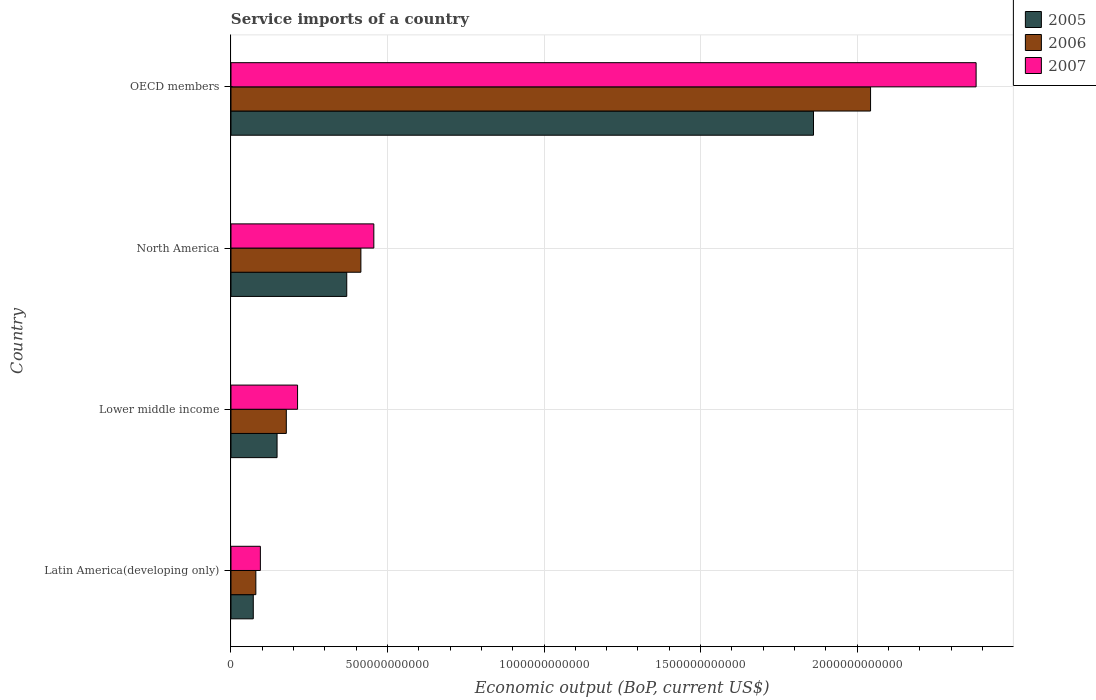How many different coloured bars are there?
Your response must be concise. 3. Are the number of bars per tick equal to the number of legend labels?
Keep it short and to the point. Yes. Are the number of bars on each tick of the Y-axis equal?
Provide a short and direct response. Yes. How many bars are there on the 2nd tick from the top?
Your answer should be compact. 3. How many bars are there on the 3rd tick from the bottom?
Provide a succinct answer. 3. What is the service imports in 2007 in North America?
Your response must be concise. 4.56e+11. Across all countries, what is the maximum service imports in 2006?
Give a very brief answer. 2.04e+12. Across all countries, what is the minimum service imports in 2005?
Offer a terse response. 7.13e+1. In which country was the service imports in 2007 minimum?
Make the answer very short. Latin America(developing only). What is the total service imports in 2006 in the graph?
Your answer should be very brief. 2.71e+12. What is the difference between the service imports in 2005 in North America and that in OECD members?
Your response must be concise. -1.49e+12. What is the difference between the service imports in 2005 in Lower middle income and the service imports in 2007 in Latin America(developing only)?
Ensure brevity in your answer.  5.33e+1. What is the average service imports in 2007 per country?
Make the answer very short. 7.86e+11. What is the difference between the service imports in 2007 and service imports in 2005 in Latin America(developing only)?
Give a very brief answer. 2.26e+1. In how many countries, is the service imports in 2006 greater than 800000000000 US$?
Provide a succinct answer. 1. What is the ratio of the service imports in 2007 in Lower middle income to that in OECD members?
Your answer should be compact. 0.09. Is the service imports in 2005 in Lower middle income less than that in North America?
Provide a succinct answer. Yes. What is the difference between the highest and the second highest service imports in 2007?
Offer a very short reply. 1.92e+12. What is the difference between the highest and the lowest service imports in 2005?
Ensure brevity in your answer.  1.79e+12. In how many countries, is the service imports in 2006 greater than the average service imports in 2006 taken over all countries?
Your answer should be very brief. 1. What does the 1st bar from the top in Latin America(developing only) represents?
Provide a succinct answer. 2007. What does the 2nd bar from the bottom in Lower middle income represents?
Provide a succinct answer. 2006. Is it the case that in every country, the sum of the service imports in 2005 and service imports in 2006 is greater than the service imports in 2007?
Make the answer very short. Yes. What is the difference between two consecutive major ticks on the X-axis?
Provide a succinct answer. 5.00e+11. Where does the legend appear in the graph?
Ensure brevity in your answer.  Top right. How many legend labels are there?
Provide a short and direct response. 3. What is the title of the graph?
Keep it short and to the point. Service imports of a country. Does "1982" appear as one of the legend labels in the graph?
Your answer should be very brief. No. What is the label or title of the X-axis?
Give a very brief answer. Economic output (BoP, current US$). What is the label or title of the Y-axis?
Ensure brevity in your answer.  Country. What is the Economic output (BoP, current US$) of 2005 in Latin America(developing only)?
Ensure brevity in your answer.  7.13e+1. What is the Economic output (BoP, current US$) in 2006 in Latin America(developing only)?
Provide a succinct answer. 7.94e+1. What is the Economic output (BoP, current US$) in 2007 in Latin America(developing only)?
Ensure brevity in your answer.  9.39e+1. What is the Economic output (BoP, current US$) in 2005 in Lower middle income?
Keep it short and to the point. 1.47e+11. What is the Economic output (BoP, current US$) of 2006 in Lower middle income?
Ensure brevity in your answer.  1.77e+11. What is the Economic output (BoP, current US$) in 2007 in Lower middle income?
Provide a short and direct response. 2.13e+11. What is the Economic output (BoP, current US$) in 2005 in North America?
Your answer should be compact. 3.70e+11. What is the Economic output (BoP, current US$) of 2006 in North America?
Ensure brevity in your answer.  4.15e+11. What is the Economic output (BoP, current US$) of 2007 in North America?
Your response must be concise. 4.56e+11. What is the Economic output (BoP, current US$) in 2005 in OECD members?
Your answer should be very brief. 1.86e+12. What is the Economic output (BoP, current US$) of 2006 in OECD members?
Provide a short and direct response. 2.04e+12. What is the Economic output (BoP, current US$) in 2007 in OECD members?
Give a very brief answer. 2.38e+12. Across all countries, what is the maximum Economic output (BoP, current US$) in 2005?
Your answer should be very brief. 1.86e+12. Across all countries, what is the maximum Economic output (BoP, current US$) of 2006?
Offer a very short reply. 2.04e+12. Across all countries, what is the maximum Economic output (BoP, current US$) of 2007?
Offer a very short reply. 2.38e+12. Across all countries, what is the minimum Economic output (BoP, current US$) in 2005?
Make the answer very short. 7.13e+1. Across all countries, what is the minimum Economic output (BoP, current US$) of 2006?
Provide a short and direct response. 7.94e+1. Across all countries, what is the minimum Economic output (BoP, current US$) in 2007?
Provide a short and direct response. 9.39e+1. What is the total Economic output (BoP, current US$) of 2005 in the graph?
Offer a terse response. 2.45e+12. What is the total Economic output (BoP, current US$) in 2006 in the graph?
Your response must be concise. 2.71e+12. What is the total Economic output (BoP, current US$) in 2007 in the graph?
Ensure brevity in your answer.  3.14e+12. What is the difference between the Economic output (BoP, current US$) in 2005 in Latin America(developing only) and that in Lower middle income?
Your answer should be compact. -7.59e+1. What is the difference between the Economic output (BoP, current US$) in 2006 in Latin America(developing only) and that in Lower middle income?
Keep it short and to the point. -9.73e+1. What is the difference between the Economic output (BoP, current US$) in 2007 in Latin America(developing only) and that in Lower middle income?
Keep it short and to the point. -1.19e+11. What is the difference between the Economic output (BoP, current US$) of 2005 in Latin America(developing only) and that in North America?
Provide a short and direct response. -2.99e+11. What is the difference between the Economic output (BoP, current US$) in 2006 in Latin America(developing only) and that in North America?
Keep it short and to the point. -3.36e+11. What is the difference between the Economic output (BoP, current US$) in 2007 in Latin America(developing only) and that in North America?
Provide a succinct answer. -3.62e+11. What is the difference between the Economic output (BoP, current US$) of 2005 in Latin America(developing only) and that in OECD members?
Offer a terse response. -1.79e+12. What is the difference between the Economic output (BoP, current US$) of 2006 in Latin America(developing only) and that in OECD members?
Keep it short and to the point. -1.96e+12. What is the difference between the Economic output (BoP, current US$) in 2007 in Latin America(developing only) and that in OECD members?
Offer a terse response. -2.29e+12. What is the difference between the Economic output (BoP, current US$) of 2005 in Lower middle income and that in North America?
Make the answer very short. -2.23e+11. What is the difference between the Economic output (BoP, current US$) in 2006 in Lower middle income and that in North America?
Ensure brevity in your answer.  -2.38e+11. What is the difference between the Economic output (BoP, current US$) in 2007 in Lower middle income and that in North America?
Make the answer very short. -2.44e+11. What is the difference between the Economic output (BoP, current US$) of 2005 in Lower middle income and that in OECD members?
Make the answer very short. -1.71e+12. What is the difference between the Economic output (BoP, current US$) of 2006 in Lower middle income and that in OECD members?
Offer a terse response. -1.87e+12. What is the difference between the Economic output (BoP, current US$) of 2007 in Lower middle income and that in OECD members?
Your answer should be compact. -2.17e+12. What is the difference between the Economic output (BoP, current US$) in 2005 in North America and that in OECD members?
Keep it short and to the point. -1.49e+12. What is the difference between the Economic output (BoP, current US$) of 2006 in North America and that in OECD members?
Offer a terse response. -1.63e+12. What is the difference between the Economic output (BoP, current US$) of 2007 in North America and that in OECD members?
Offer a terse response. -1.92e+12. What is the difference between the Economic output (BoP, current US$) in 2005 in Latin America(developing only) and the Economic output (BoP, current US$) in 2006 in Lower middle income?
Provide a succinct answer. -1.05e+11. What is the difference between the Economic output (BoP, current US$) of 2005 in Latin America(developing only) and the Economic output (BoP, current US$) of 2007 in Lower middle income?
Provide a short and direct response. -1.41e+11. What is the difference between the Economic output (BoP, current US$) in 2006 in Latin America(developing only) and the Economic output (BoP, current US$) in 2007 in Lower middle income?
Offer a terse response. -1.33e+11. What is the difference between the Economic output (BoP, current US$) of 2005 in Latin America(developing only) and the Economic output (BoP, current US$) of 2006 in North America?
Your response must be concise. -3.44e+11. What is the difference between the Economic output (BoP, current US$) in 2005 in Latin America(developing only) and the Economic output (BoP, current US$) in 2007 in North America?
Offer a terse response. -3.85e+11. What is the difference between the Economic output (BoP, current US$) of 2006 in Latin America(developing only) and the Economic output (BoP, current US$) of 2007 in North America?
Offer a terse response. -3.77e+11. What is the difference between the Economic output (BoP, current US$) of 2005 in Latin America(developing only) and the Economic output (BoP, current US$) of 2006 in OECD members?
Your answer should be very brief. -1.97e+12. What is the difference between the Economic output (BoP, current US$) in 2005 in Latin America(developing only) and the Economic output (BoP, current US$) in 2007 in OECD members?
Your answer should be compact. -2.31e+12. What is the difference between the Economic output (BoP, current US$) in 2006 in Latin America(developing only) and the Economic output (BoP, current US$) in 2007 in OECD members?
Your answer should be compact. -2.30e+12. What is the difference between the Economic output (BoP, current US$) of 2005 in Lower middle income and the Economic output (BoP, current US$) of 2006 in North America?
Offer a very short reply. -2.68e+11. What is the difference between the Economic output (BoP, current US$) of 2005 in Lower middle income and the Economic output (BoP, current US$) of 2007 in North America?
Your response must be concise. -3.09e+11. What is the difference between the Economic output (BoP, current US$) of 2006 in Lower middle income and the Economic output (BoP, current US$) of 2007 in North America?
Offer a very short reply. -2.80e+11. What is the difference between the Economic output (BoP, current US$) in 2005 in Lower middle income and the Economic output (BoP, current US$) in 2006 in OECD members?
Provide a succinct answer. -1.90e+12. What is the difference between the Economic output (BoP, current US$) of 2005 in Lower middle income and the Economic output (BoP, current US$) of 2007 in OECD members?
Offer a very short reply. -2.23e+12. What is the difference between the Economic output (BoP, current US$) in 2006 in Lower middle income and the Economic output (BoP, current US$) in 2007 in OECD members?
Your answer should be very brief. -2.20e+12. What is the difference between the Economic output (BoP, current US$) in 2005 in North America and the Economic output (BoP, current US$) in 2006 in OECD members?
Ensure brevity in your answer.  -1.67e+12. What is the difference between the Economic output (BoP, current US$) in 2005 in North America and the Economic output (BoP, current US$) in 2007 in OECD members?
Offer a very short reply. -2.01e+12. What is the difference between the Economic output (BoP, current US$) in 2006 in North America and the Economic output (BoP, current US$) in 2007 in OECD members?
Give a very brief answer. -1.97e+12. What is the average Economic output (BoP, current US$) in 2005 per country?
Ensure brevity in your answer.  6.12e+11. What is the average Economic output (BoP, current US$) in 2006 per country?
Your answer should be very brief. 6.78e+11. What is the average Economic output (BoP, current US$) of 2007 per country?
Your response must be concise. 7.86e+11. What is the difference between the Economic output (BoP, current US$) of 2005 and Economic output (BoP, current US$) of 2006 in Latin America(developing only)?
Offer a very short reply. -8.14e+09. What is the difference between the Economic output (BoP, current US$) of 2005 and Economic output (BoP, current US$) of 2007 in Latin America(developing only)?
Keep it short and to the point. -2.26e+1. What is the difference between the Economic output (BoP, current US$) in 2006 and Economic output (BoP, current US$) in 2007 in Latin America(developing only)?
Provide a succinct answer. -1.45e+1. What is the difference between the Economic output (BoP, current US$) in 2005 and Economic output (BoP, current US$) in 2006 in Lower middle income?
Keep it short and to the point. -2.95e+1. What is the difference between the Economic output (BoP, current US$) of 2005 and Economic output (BoP, current US$) of 2007 in Lower middle income?
Your answer should be very brief. -6.55e+1. What is the difference between the Economic output (BoP, current US$) in 2006 and Economic output (BoP, current US$) in 2007 in Lower middle income?
Keep it short and to the point. -3.59e+1. What is the difference between the Economic output (BoP, current US$) of 2005 and Economic output (BoP, current US$) of 2006 in North America?
Give a very brief answer. -4.52e+1. What is the difference between the Economic output (BoP, current US$) of 2005 and Economic output (BoP, current US$) of 2007 in North America?
Ensure brevity in your answer.  -8.65e+1. What is the difference between the Economic output (BoP, current US$) of 2006 and Economic output (BoP, current US$) of 2007 in North America?
Give a very brief answer. -4.13e+1. What is the difference between the Economic output (BoP, current US$) in 2005 and Economic output (BoP, current US$) in 2006 in OECD members?
Offer a very short reply. -1.82e+11. What is the difference between the Economic output (BoP, current US$) of 2005 and Economic output (BoP, current US$) of 2007 in OECD members?
Provide a succinct answer. -5.19e+11. What is the difference between the Economic output (BoP, current US$) in 2006 and Economic output (BoP, current US$) in 2007 in OECD members?
Keep it short and to the point. -3.37e+11. What is the ratio of the Economic output (BoP, current US$) in 2005 in Latin America(developing only) to that in Lower middle income?
Your answer should be very brief. 0.48. What is the ratio of the Economic output (BoP, current US$) of 2006 in Latin America(developing only) to that in Lower middle income?
Your response must be concise. 0.45. What is the ratio of the Economic output (BoP, current US$) in 2007 in Latin America(developing only) to that in Lower middle income?
Your answer should be very brief. 0.44. What is the ratio of the Economic output (BoP, current US$) of 2005 in Latin America(developing only) to that in North America?
Provide a succinct answer. 0.19. What is the ratio of the Economic output (BoP, current US$) of 2006 in Latin America(developing only) to that in North America?
Provide a succinct answer. 0.19. What is the ratio of the Economic output (BoP, current US$) of 2007 in Latin America(developing only) to that in North America?
Ensure brevity in your answer.  0.21. What is the ratio of the Economic output (BoP, current US$) in 2005 in Latin America(developing only) to that in OECD members?
Ensure brevity in your answer.  0.04. What is the ratio of the Economic output (BoP, current US$) in 2006 in Latin America(developing only) to that in OECD members?
Keep it short and to the point. 0.04. What is the ratio of the Economic output (BoP, current US$) of 2007 in Latin America(developing only) to that in OECD members?
Your answer should be compact. 0.04. What is the ratio of the Economic output (BoP, current US$) of 2005 in Lower middle income to that in North America?
Provide a succinct answer. 0.4. What is the ratio of the Economic output (BoP, current US$) of 2006 in Lower middle income to that in North America?
Your response must be concise. 0.43. What is the ratio of the Economic output (BoP, current US$) of 2007 in Lower middle income to that in North America?
Your answer should be compact. 0.47. What is the ratio of the Economic output (BoP, current US$) of 2005 in Lower middle income to that in OECD members?
Your answer should be compact. 0.08. What is the ratio of the Economic output (BoP, current US$) of 2006 in Lower middle income to that in OECD members?
Ensure brevity in your answer.  0.09. What is the ratio of the Economic output (BoP, current US$) of 2007 in Lower middle income to that in OECD members?
Ensure brevity in your answer.  0.09. What is the ratio of the Economic output (BoP, current US$) of 2005 in North America to that in OECD members?
Keep it short and to the point. 0.2. What is the ratio of the Economic output (BoP, current US$) of 2006 in North America to that in OECD members?
Ensure brevity in your answer.  0.2. What is the ratio of the Economic output (BoP, current US$) of 2007 in North America to that in OECD members?
Give a very brief answer. 0.19. What is the difference between the highest and the second highest Economic output (BoP, current US$) in 2005?
Your answer should be compact. 1.49e+12. What is the difference between the highest and the second highest Economic output (BoP, current US$) in 2006?
Provide a short and direct response. 1.63e+12. What is the difference between the highest and the second highest Economic output (BoP, current US$) of 2007?
Ensure brevity in your answer.  1.92e+12. What is the difference between the highest and the lowest Economic output (BoP, current US$) in 2005?
Offer a terse response. 1.79e+12. What is the difference between the highest and the lowest Economic output (BoP, current US$) in 2006?
Keep it short and to the point. 1.96e+12. What is the difference between the highest and the lowest Economic output (BoP, current US$) of 2007?
Make the answer very short. 2.29e+12. 